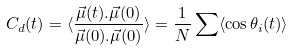<formula> <loc_0><loc_0><loc_500><loc_500>C _ { d } ( t ) = \langle \frac { \vec { \mu } ( t ) . \vec { \mu } ( 0 ) } { \vec { \mu } ( 0 ) . \vec { \mu } ( 0 ) } \rangle = \frac { 1 } { N } \sum \langle \cos \theta _ { i } ( t ) \rangle</formula> 